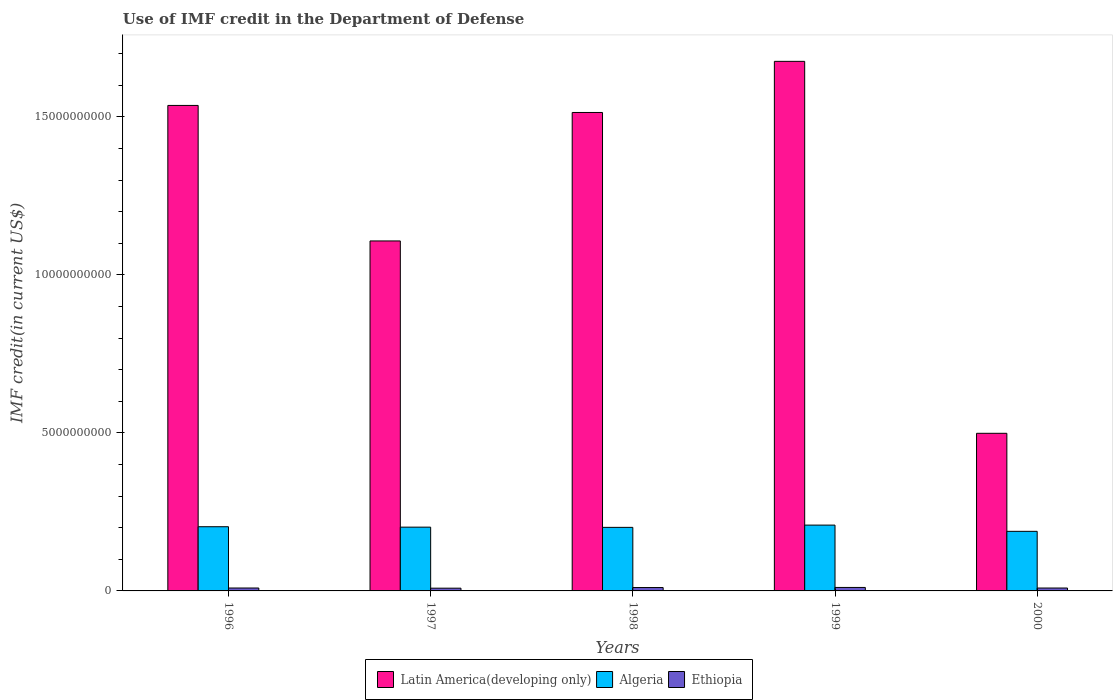How many different coloured bars are there?
Ensure brevity in your answer.  3. How many groups of bars are there?
Provide a short and direct response. 5. Are the number of bars on each tick of the X-axis equal?
Offer a very short reply. Yes. How many bars are there on the 2nd tick from the left?
Your answer should be very brief. 3. What is the label of the 2nd group of bars from the left?
Your answer should be compact. 1997. What is the IMF credit in the Department of Defense in Ethiopia in 1998?
Offer a terse response. 1.07e+08. Across all years, what is the maximum IMF credit in the Department of Defense in Ethiopia?
Ensure brevity in your answer.  1.10e+08. Across all years, what is the minimum IMF credit in the Department of Defense in Algeria?
Keep it short and to the point. 1.89e+09. In which year was the IMF credit in the Department of Defense in Ethiopia maximum?
Keep it short and to the point. 1999. What is the total IMF credit in the Department of Defense in Algeria in the graph?
Keep it short and to the point. 1.00e+1. What is the difference between the IMF credit in the Department of Defense in Algeria in 1996 and that in 1999?
Make the answer very short. -5.15e+07. What is the difference between the IMF credit in the Department of Defense in Algeria in 1997 and the IMF credit in the Department of Defense in Latin America(developing only) in 1998?
Provide a succinct answer. -1.31e+1. What is the average IMF credit in the Department of Defense in Ethiopia per year?
Your answer should be compact. 9.75e+07. In the year 1999, what is the difference between the IMF credit in the Department of Defense in Latin America(developing only) and IMF credit in the Department of Defense in Ethiopia?
Keep it short and to the point. 1.66e+1. In how many years, is the IMF credit in the Department of Defense in Algeria greater than 3000000000 US$?
Offer a very short reply. 0. What is the ratio of the IMF credit in the Department of Defense in Latin America(developing only) in 1996 to that in 2000?
Your response must be concise. 3.08. Is the difference between the IMF credit in the Department of Defense in Latin America(developing only) in 1998 and 2000 greater than the difference between the IMF credit in the Department of Defense in Ethiopia in 1998 and 2000?
Keep it short and to the point. Yes. What is the difference between the highest and the second highest IMF credit in the Department of Defense in Ethiopia?
Keep it short and to the point. 2.92e+06. What is the difference between the highest and the lowest IMF credit in the Department of Defense in Algeria?
Keep it short and to the point. 1.97e+08. Is the sum of the IMF credit in the Department of Defense in Ethiopia in 1996 and 2000 greater than the maximum IMF credit in the Department of Defense in Latin America(developing only) across all years?
Offer a terse response. No. What does the 1st bar from the left in 2000 represents?
Provide a short and direct response. Latin America(developing only). What does the 2nd bar from the right in 1996 represents?
Your answer should be very brief. Algeria. How many years are there in the graph?
Keep it short and to the point. 5. Are the values on the major ticks of Y-axis written in scientific E-notation?
Give a very brief answer. No. Does the graph contain any zero values?
Offer a terse response. No. Does the graph contain grids?
Keep it short and to the point. No. Where does the legend appear in the graph?
Keep it short and to the point. Bottom center. How many legend labels are there?
Keep it short and to the point. 3. How are the legend labels stacked?
Provide a short and direct response. Horizontal. What is the title of the graph?
Give a very brief answer. Use of IMF credit in the Department of Defense. What is the label or title of the Y-axis?
Make the answer very short. IMF credit(in current US$). What is the IMF credit(in current US$) in Latin America(developing only) in 1996?
Give a very brief answer. 1.54e+1. What is the IMF credit(in current US$) of Algeria in 1996?
Keep it short and to the point. 2.03e+09. What is the IMF credit(in current US$) of Ethiopia in 1996?
Your answer should be compact. 9.23e+07. What is the IMF credit(in current US$) of Latin America(developing only) in 1997?
Your answer should be compact. 1.11e+1. What is the IMF credit(in current US$) in Algeria in 1997?
Make the answer very short. 2.02e+09. What is the IMF credit(in current US$) in Ethiopia in 1997?
Provide a short and direct response. 8.66e+07. What is the IMF credit(in current US$) in Latin America(developing only) in 1998?
Ensure brevity in your answer.  1.51e+1. What is the IMF credit(in current US$) of Algeria in 1998?
Offer a terse response. 2.01e+09. What is the IMF credit(in current US$) in Ethiopia in 1998?
Your answer should be compact. 1.07e+08. What is the IMF credit(in current US$) of Latin America(developing only) in 1999?
Offer a very short reply. 1.68e+1. What is the IMF credit(in current US$) in Algeria in 1999?
Your response must be concise. 2.08e+09. What is the IMF credit(in current US$) of Ethiopia in 1999?
Provide a succinct answer. 1.10e+08. What is the IMF credit(in current US$) in Latin America(developing only) in 2000?
Give a very brief answer. 4.99e+09. What is the IMF credit(in current US$) of Algeria in 2000?
Your response must be concise. 1.89e+09. What is the IMF credit(in current US$) in Ethiopia in 2000?
Offer a very short reply. 9.16e+07. Across all years, what is the maximum IMF credit(in current US$) of Latin America(developing only)?
Ensure brevity in your answer.  1.68e+1. Across all years, what is the maximum IMF credit(in current US$) in Algeria?
Your answer should be very brief. 2.08e+09. Across all years, what is the maximum IMF credit(in current US$) of Ethiopia?
Keep it short and to the point. 1.10e+08. Across all years, what is the minimum IMF credit(in current US$) of Latin America(developing only)?
Provide a short and direct response. 4.99e+09. Across all years, what is the minimum IMF credit(in current US$) in Algeria?
Ensure brevity in your answer.  1.89e+09. Across all years, what is the minimum IMF credit(in current US$) in Ethiopia?
Give a very brief answer. 8.66e+07. What is the total IMF credit(in current US$) in Latin America(developing only) in the graph?
Your answer should be very brief. 6.33e+1. What is the total IMF credit(in current US$) in Algeria in the graph?
Provide a succinct answer. 1.00e+1. What is the total IMF credit(in current US$) in Ethiopia in the graph?
Your response must be concise. 4.88e+08. What is the difference between the IMF credit(in current US$) in Latin America(developing only) in 1996 and that in 1997?
Offer a very short reply. 4.29e+09. What is the difference between the IMF credit(in current US$) of Algeria in 1996 and that in 1997?
Give a very brief answer. 1.34e+07. What is the difference between the IMF credit(in current US$) in Ethiopia in 1996 and that in 1997?
Give a very brief answer. 5.69e+06. What is the difference between the IMF credit(in current US$) of Latin America(developing only) in 1996 and that in 1998?
Give a very brief answer. 2.23e+08. What is the difference between the IMF credit(in current US$) in Algeria in 1996 and that in 1998?
Offer a very short reply. 2.05e+07. What is the difference between the IMF credit(in current US$) in Ethiopia in 1996 and that in 1998?
Give a very brief answer. -1.49e+07. What is the difference between the IMF credit(in current US$) of Latin America(developing only) in 1996 and that in 1999?
Your answer should be compact. -1.39e+09. What is the difference between the IMF credit(in current US$) in Algeria in 1996 and that in 1999?
Offer a very short reply. -5.15e+07. What is the difference between the IMF credit(in current US$) in Ethiopia in 1996 and that in 1999?
Your response must be concise. -1.78e+07. What is the difference between the IMF credit(in current US$) of Latin America(developing only) in 1996 and that in 2000?
Make the answer very short. 1.04e+1. What is the difference between the IMF credit(in current US$) of Algeria in 1996 and that in 2000?
Your response must be concise. 1.46e+08. What is the difference between the IMF credit(in current US$) in Ethiopia in 1996 and that in 2000?
Keep it short and to the point. 6.70e+05. What is the difference between the IMF credit(in current US$) in Latin America(developing only) in 1997 and that in 1998?
Ensure brevity in your answer.  -4.06e+09. What is the difference between the IMF credit(in current US$) in Algeria in 1997 and that in 1998?
Give a very brief answer. 7.11e+06. What is the difference between the IMF credit(in current US$) of Ethiopia in 1997 and that in 1998?
Provide a succinct answer. -2.06e+07. What is the difference between the IMF credit(in current US$) of Latin America(developing only) in 1997 and that in 1999?
Your response must be concise. -5.68e+09. What is the difference between the IMF credit(in current US$) in Algeria in 1997 and that in 1999?
Your answer should be very brief. -6.48e+07. What is the difference between the IMF credit(in current US$) in Ethiopia in 1997 and that in 1999?
Provide a succinct answer. -2.35e+07. What is the difference between the IMF credit(in current US$) in Latin America(developing only) in 1997 and that in 2000?
Your answer should be compact. 6.09e+09. What is the difference between the IMF credit(in current US$) in Algeria in 1997 and that in 2000?
Provide a succinct answer. 1.32e+08. What is the difference between the IMF credit(in current US$) of Ethiopia in 1997 and that in 2000?
Keep it short and to the point. -5.02e+06. What is the difference between the IMF credit(in current US$) of Latin America(developing only) in 1998 and that in 1999?
Your response must be concise. -1.62e+09. What is the difference between the IMF credit(in current US$) of Algeria in 1998 and that in 1999?
Give a very brief answer. -7.19e+07. What is the difference between the IMF credit(in current US$) of Ethiopia in 1998 and that in 1999?
Give a very brief answer. -2.92e+06. What is the difference between the IMF credit(in current US$) in Latin America(developing only) in 1998 and that in 2000?
Provide a short and direct response. 1.02e+1. What is the difference between the IMF credit(in current US$) in Algeria in 1998 and that in 2000?
Your answer should be very brief. 1.25e+08. What is the difference between the IMF credit(in current US$) in Ethiopia in 1998 and that in 2000?
Your answer should be compact. 1.55e+07. What is the difference between the IMF credit(in current US$) of Latin America(developing only) in 1999 and that in 2000?
Provide a short and direct response. 1.18e+1. What is the difference between the IMF credit(in current US$) of Algeria in 1999 and that in 2000?
Your answer should be compact. 1.97e+08. What is the difference between the IMF credit(in current US$) of Ethiopia in 1999 and that in 2000?
Your answer should be very brief. 1.85e+07. What is the difference between the IMF credit(in current US$) of Latin America(developing only) in 1996 and the IMF credit(in current US$) of Algeria in 1997?
Your answer should be very brief. 1.33e+1. What is the difference between the IMF credit(in current US$) of Latin America(developing only) in 1996 and the IMF credit(in current US$) of Ethiopia in 1997?
Give a very brief answer. 1.53e+1. What is the difference between the IMF credit(in current US$) in Algeria in 1996 and the IMF credit(in current US$) in Ethiopia in 1997?
Your answer should be compact. 1.94e+09. What is the difference between the IMF credit(in current US$) of Latin America(developing only) in 1996 and the IMF credit(in current US$) of Algeria in 1998?
Your answer should be compact. 1.34e+1. What is the difference between the IMF credit(in current US$) in Latin America(developing only) in 1996 and the IMF credit(in current US$) in Ethiopia in 1998?
Your answer should be compact. 1.53e+1. What is the difference between the IMF credit(in current US$) in Algeria in 1996 and the IMF credit(in current US$) in Ethiopia in 1998?
Your response must be concise. 1.92e+09. What is the difference between the IMF credit(in current US$) of Latin America(developing only) in 1996 and the IMF credit(in current US$) of Algeria in 1999?
Offer a terse response. 1.33e+1. What is the difference between the IMF credit(in current US$) in Latin America(developing only) in 1996 and the IMF credit(in current US$) in Ethiopia in 1999?
Offer a terse response. 1.53e+1. What is the difference between the IMF credit(in current US$) of Algeria in 1996 and the IMF credit(in current US$) of Ethiopia in 1999?
Your response must be concise. 1.92e+09. What is the difference between the IMF credit(in current US$) of Latin America(developing only) in 1996 and the IMF credit(in current US$) of Algeria in 2000?
Ensure brevity in your answer.  1.35e+1. What is the difference between the IMF credit(in current US$) in Latin America(developing only) in 1996 and the IMF credit(in current US$) in Ethiopia in 2000?
Keep it short and to the point. 1.53e+1. What is the difference between the IMF credit(in current US$) in Algeria in 1996 and the IMF credit(in current US$) in Ethiopia in 2000?
Your response must be concise. 1.94e+09. What is the difference between the IMF credit(in current US$) of Latin America(developing only) in 1997 and the IMF credit(in current US$) of Algeria in 1998?
Give a very brief answer. 9.06e+09. What is the difference between the IMF credit(in current US$) in Latin America(developing only) in 1997 and the IMF credit(in current US$) in Ethiopia in 1998?
Offer a terse response. 1.10e+1. What is the difference between the IMF credit(in current US$) of Algeria in 1997 and the IMF credit(in current US$) of Ethiopia in 1998?
Your response must be concise. 1.91e+09. What is the difference between the IMF credit(in current US$) of Latin America(developing only) in 1997 and the IMF credit(in current US$) of Algeria in 1999?
Your answer should be very brief. 8.99e+09. What is the difference between the IMF credit(in current US$) of Latin America(developing only) in 1997 and the IMF credit(in current US$) of Ethiopia in 1999?
Provide a short and direct response. 1.10e+1. What is the difference between the IMF credit(in current US$) of Algeria in 1997 and the IMF credit(in current US$) of Ethiopia in 1999?
Make the answer very short. 1.91e+09. What is the difference between the IMF credit(in current US$) of Latin America(developing only) in 1997 and the IMF credit(in current US$) of Algeria in 2000?
Provide a short and direct response. 9.19e+09. What is the difference between the IMF credit(in current US$) of Latin America(developing only) in 1997 and the IMF credit(in current US$) of Ethiopia in 2000?
Provide a short and direct response. 1.10e+1. What is the difference between the IMF credit(in current US$) of Algeria in 1997 and the IMF credit(in current US$) of Ethiopia in 2000?
Your answer should be very brief. 1.93e+09. What is the difference between the IMF credit(in current US$) in Latin America(developing only) in 1998 and the IMF credit(in current US$) in Algeria in 1999?
Your answer should be compact. 1.31e+1. What is the difference between the IMF credit(in current US$) in Latin America(developing only) in 1998 and the IMF credit(in current US$) in Ethiopia in 1999?
Ensure brevity in your answer.  1.50e+1. What is the difference between the IMF credit(in current US$) of Algeria in 1998 and the IMF credit(in current US$) of Ethiopia in 1999?
Give a very brief answer. 1.90e+09. What is the difference between the IMF credit(in current US$) in Latin America(developing only) in 1998 and the IMF credit(in current US$) in Algeria in 2000?
Offer a very short reply. 1.33e+1. What is the difference between the IMF credit(in current US$) of Latin America(developing only) in 1998 and the IMF credit(in current US$) of Ethiopia in 2000?
Keep it short and to the point. 1.50e+1. What is the difference between the IMF credit(in current US$) of Algeria in 1998 and the IMF credit(in current US$) of Ethiopia in 2000?
Make the answer very short. 1.92e+09. What is the difference between the IMF credit(in current US$) in Latin America(developing only) in 1999 and the IMF credit(in current US$) in Algeria in 2000?
Provide a succinct answer. 1.49e+1. What is the difference between the IMF credit(in current US$) in Latin America(developing only) in 1999 and the IMF credit(in current US$) in Ethiopia in 2000?
Provide a succinct answer. 1.67e+1. What is the difference between the IMF credit(in current US$) of Algeria in 1999 and the IMF credit(in current US$) of Ethiopia in 2000?
Your answer should be very brief. 1.99e+09. What is the average IMF credit(in current US$) of Latin America(developing only) per year?
Ensure brevity in your answer.  1.27e+1. What is the average IMF credit(in current US$) in Algeria per year?
Give a very brief answer. 2.01e+09. What is the average IMF credit(in current US$) in Ethiopia per year?
Provide a succinct answer. 9.75e+07. In the year 1996, what is the difference between the IMF credit(in current US$) in Latin America(developing only) and IMF credit(in current US$) in Algeria?
Make the answer very short. 1.33e+1. In the year 1996, what is the difference between the IMF credit(in current US$) in Latin America(developing only) and IMF credit(in current US$) in Ethiopia?
Give a very brief answer. 1.53e+1. In the year 1996, what is the difference between the IMF credit(in current US$) of Algeria and IMF credit(in current US$) of Ethiopia?
Offer a very short reply. 1.94e+09. In the year 1997, what is the difference between the IMF credit(in current US$) of Latin America(developing only) and IMF credit(in current US$) of Algeria?
Provide a succinct answer. 9.06e+09. In the year 1997, what is the difference between the IMF credit(in current US$) of Latin America(developing only) and IMF credit(in current US$) of Ethiopia?
Your answer should be compact. 1.10e+1. In the year 1997, what is the difference between the IMF credit(in current US$) in Algeria and IMF credit(in current US$) in Ethiopia?
Ensure brevity in your answer.  1.93e+09. In the year 1998, what is the difference between the IMF credit(in current US$) in Latin America(developing only) and IMF credit(in current US$) in Algeria?
Offer a terse response. 1.31e+1. In the year 1998, what is the difference between the IMF credit(in current US$) of Latin America(developing only) and IMF credit(in current US$) of Ethiopia?
Give a very brief answer. 1.50e+1. In the year 1998, what is the difference between the IMF credit(in current US$) of Algeria and IMF credit(in current US$) of Ethiopia?
Provide a succinct answer. 1.90e+09. In the year 1999, what is the difference between the IMF credit(in current US$) in Latin America(developing only) and IMF credit(in current US$) in Algeria?
Your answer should be compact. 1.47e+1. In the year 1999, what is the difference between the IMF credit(in current US$) of Latin America(developing only) and IMF credit(in current US$) of Ethiopia?
Provide a succinct answer. 1.66e+1. In the year 1999, what is the difference between the IMF credit(in current US$) in Algeria and IMF credit(in current US$) in Ethiopia?
Give a very brief answer. 1.97e+09. In the year 2000, what is the difference between the IMF credit(in current US$) in Latin America(developing only) and IMF credit(in current US$) in Algeria?
Provide a succinct answer. 3.10e+09. In the year 2000, what is the difference between the IMF credit(in current US$) in Latin America(developing only) and IMF credit(in current US$) in Ethiopia?
Your response must be concise. 4.90e+09. In the year 2000, what is the difference between the IMF credit(in current US$) in Algeria and IMF credit(in current US$) in Ethiopia?
Provide a short and direct response. 1.79e+09. What is the ratio of the IMF credit(in current US$) of Latin America(developing only) in 1996 to that in 1997?
Make the answer very short. 1.39. What is the ratio of the IMF credit(in current US$) in Algeria in 1996 to that in 1997?
Provide a short and direct response. 1.01. What is the ratio of the IMF credit(in current US$) in Ethiopia in 1996 to that in 1997?
Your answer should be very brief. 1.07. What is the ratio of the IMF credit(in current US$) of Latin America(developing only) in 1996 to that in 1998?
Provide a short and direct response. 1.01. What is the ratio of the IMF credit(in current US$) of Algeria in 1996 to that in 1998?
Make the answer very short. 1.01. What is the ratio of the IMF credit(in current US$) of Ethiopia in 1996 to that in 1998?
Your response must be concise. 0.86. What is the ratio of the IMF credit(in current US$) in Latin America(developing only) in 1996 to that in 1999?
Provide a short and direct response. 0.92. What is the ratio of the IMF credit(in current US$) of Algeria in 1996 to that in 1999?
Offer a very short reply. 0.98. What is the ratio of the IMF credit(in current US$) in Ethiopia in 1996 to that in 1999?
Give a very brief answer. 0.84. What is the ratio of the IMF credit(in current US$) of Latin America(developing only) in 1996 to that in 2000?
Your answer should be compact. 3.08. What is the ratio of the IMF credit(in current US$) in Algeria in 1996 to that in 2000?
Provide a short and direct response. 1.08. What is the ratio of the IMF credit(in current US$) in Ethiopia in 1996 to that in 2000?
Offer a very short reply. 1.01. What is the ratio of the IMF credit(in current US$) in Latin America(developing only) in 1997 to that in 1998?
Provide a succinct answer. 0.73. What is the ratio of the IMF credit(in current US$) of Ethiopia in 1997 to that in 1998?
Provide a succinct answer. 0.81. What is the ratio of the IMF credit(in current US$) in Latin America(developing only) in 1997 to that in 1999?
Make the answer very short. 0.66. What is the ratio of the IMF credit(in current US$) of Algeria in 1997 to that in 1999?
Provide a succinct answer. 0.97. What is the ratio of the IMF credit(in current US$) in Ethiopia in 1997 to that in 1999?
Provide a short and direct response. 0.79. What is the ratio of the IMF credit(in current US$) in Latin America(developing only) in 1997 to that in 2000?
Your answer should be very brief. 2.22. What is the ratio of the IMF credit(in current US$) in Algeria in 1997 to that in 2000?
Provide a short and direct response. 1.07. What is the ratio of the IMF credit(in current US$) in Ethiopia in 1997 to that in 2000?
Ensure brevity in your answer.  0.95. What is the ratio of the IMF credit(in current US$) of Latin America(developing only) in 1998 to that in 1999?
Your answer should be very brief. 0.9. What is the ratio of the IMF credit(in current US$) in Algeria in 1998 to that in 1999?
Your response must be concise. 0.97. What is the ratio of the IMF credit(in current US$) in Ethiopia in 1998 to that in 1999?
Ensure brevity in your answer.  0.97. What is the ratio of the IMF credit(in current US$) in Latin America(developing only) in 1998 to that in 2000?
Your response must be concise. 3.04. What is the ratio of the IMF credit(in current US$) in Algeria in 1998 to that in 2000?
Provide a succinct answer. 1.07. What is the ratio of the IMF credit(in current US$) in Ethiopia in 1998 to that in 2000?
Keep it short and to the point. 1.17. What is the ratio of the IMF credit(in current US$) in Latin America(developing only) in 1999 to that in 2000?
Give a very brief answer. 3.36. What is the ratio of the IMF credit(in current US$) of Algeria in 1999 to that in 2000?
Offer a very short reply. 1.1. What is the ratio of the IMF credit(in current US$) in Ethiopia in 1999 to that in 2000?
Your answer should be compact. 1.2. What is the difference between the highest and the second highest IMF credit(in current US$) in Latin America(developing only)?
Provide a short and direct response. 1.39e+09. What is the difference between the highest and the second highest IMF credit(in current US$) in Algeria?
Give a very brief answer. 5.15e+07. What is the difference between the highest and the second highest IMF credit(in current US$) in Ethiopia?
Ensure brevity in your answer.  2.92e+06. What is the difference between the highest and the lowest IMF credit(in current US$) of Latin America(developing only)?
Your response must be concise. 1.18e+1. What is the difference between the highest and the lowest IMF credit(in current US$) of Algeria?
Keep it short and to the point. 1.97e+08. What is the difference between the highest and the lowest IMF credit(in current US$) of Ethiopia?
Ensure brevity in your answer.  2.35e+07. 